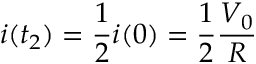<formula> <loc_0><loc_0><loc_500><loc_500>i ( t _ { 2 } ) = \frac { 1 } { 2 } i ( 0 ) = \frac { 1 } { 2 } \frac { V _ { 0 } } { R }</formula> 